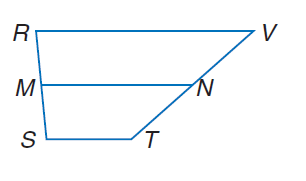Answer the mathemtical geometry problem and directly provide the correct option letter.
Question: R S T V is a trapezoid with bases R V and S T and median M N. Find x if M N = 60, S T = 4 x - 1, and R V = 6 x + 11.
Choices: A: 11 B: 44 C: 60 D: 77 A 